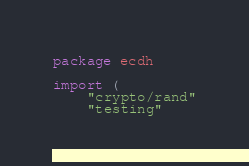Convert code to text. <code><loc_0><loc_0><loc_500><loc_500><_Go_>package ecdh

import (
	"crypto/rand"
	"testing"
</code> 